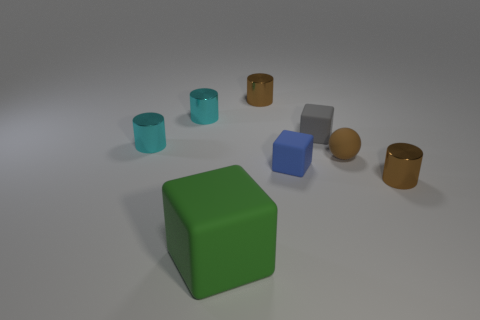What is the color of the rubber thing on the left side of the tiny brown shiny thing left of the small brown rubber object? The rubber object you're referring to on the left side of the tiny brown shiny object, which is to the left of the small brown rubber object, is not green; it appears to be cyan to light blue. It's important to note, however, that color perception can be affected by lighting in the image and individual screen settings. 